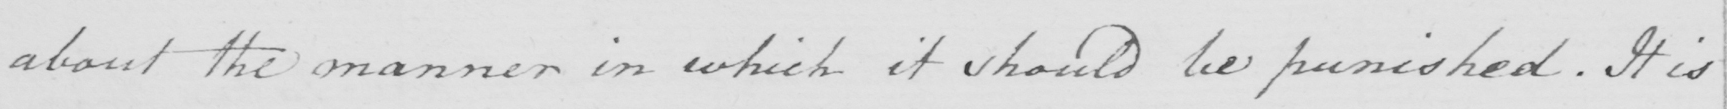What text is written in this handwritten line? about the manner in which it should be punished . It is 